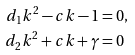Convert formula to latex. <formula><loc_0><loc_0><loc_500><loc_500>d _ { 1 } k ^ { 2 } - c k - 1 & = 0 , \\ d _ { 2 } k ^ { 2 } + c k + \gamma & = 0</formula> 